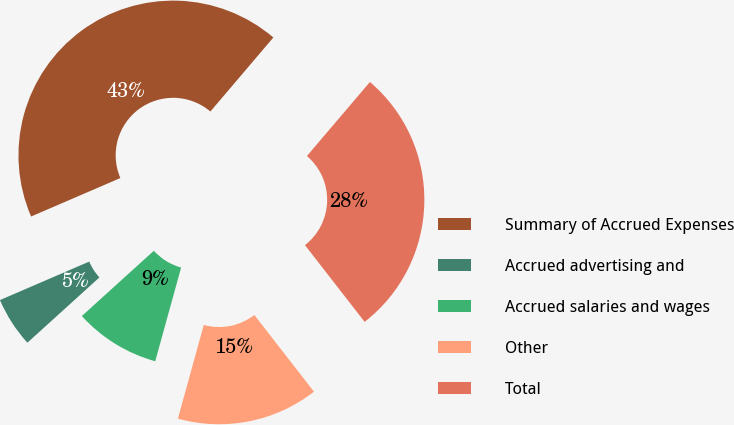Convert chart to OTSL. <chart><loc_0><loc_0><loc_500><loc_500><pie_chart><fcel>Summary of Accrued Expenses<fcel>Accrued advertising and<fcel>Accrued salaries and wages<fcel>Other<fcel>Total<nl><fcel>42.7%<fcel>5.24%<fcel>8.99%<fcel>14.81%<fcel>28.26%<nl></chart> 